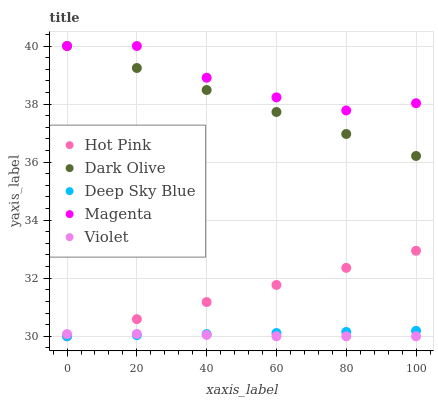Does Violet have the minimum area under the curve?
Answer yes or no. Yes. Does Magenta have the maximum area under the curve?
Answer yes or no. Yes. Does Hot Pink have the minimum area under the curve?
Answer yes or no. No. Does Hot Pink have the maximum area under the curve?
Answer yes or no. No. Is Deep Sky Blue the smoothest?
Answer yes or no. Yes. Is Magenta the roughest?
Answer yes or no. Yes. Is Hot Pink the smoothest?
Answer yes or no. No. Is Hot Pink the roughest?
Answer yes or no. No. Does Hot Pink have the lowest value?
Answer yes or no. Yes. Does Magenta have the lowest value?
Answer yes or no. No. Does Magenta have the highest value?
Answer yes or no. Yes. Does Hot Pink have the highest value?
Answer yes or no. No. Is Hot Pink less than Magenta?
Answer yes or no. Yes. Is Magenta greater than Deep Sky Blue?
Answer yes or no. Yes. Does Magenta intersect Dark Olive?
Answer yes or no. Yes. Is Magenta less than Dark Olive?
Answer yes or no. No. Is Magenta greater than Dark Olive?
Answer yes or no. No. Does Hot Pink intersect Magenta?
Answer yes or no. No. 